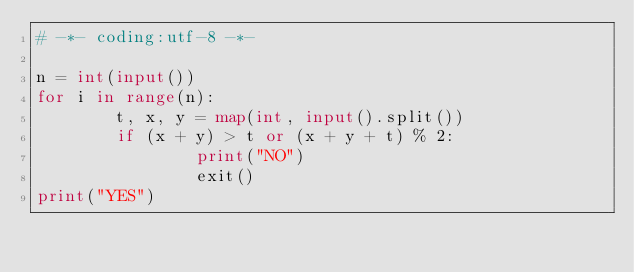<code> <loc_0><loc_0><loc_500><loc_500><_Python_># -*- coding:utf-8 -*-

n = int(input())
for i in range(n):
        t, x, y = map(int, input().split())
        if (x + y) > t or (x + y + t) % 2:
                print("NO")
                exit()
print("YES")</code> 